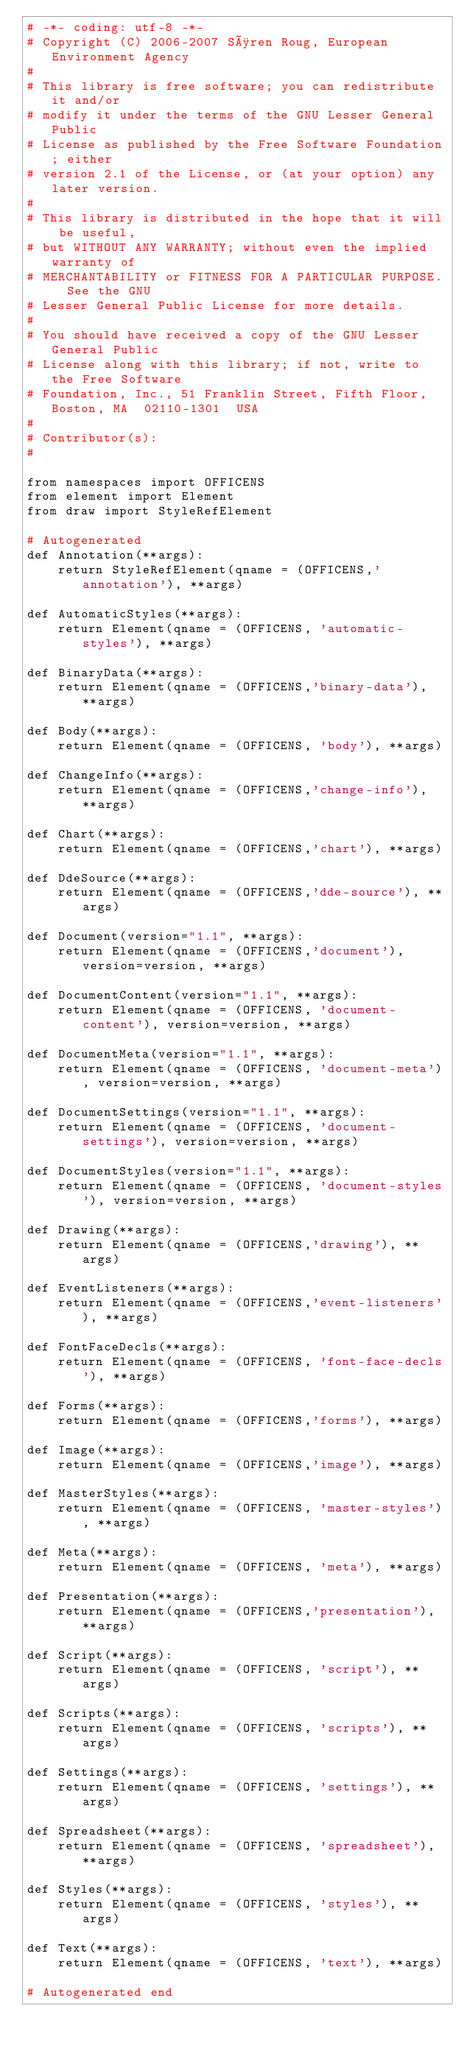<code> <loc_0><loc_0><loc_500><loc_500><_Python_># -*- coding: utf-8 -*-
# Copyright (C) 2006-2007 Søren Roug, European Environment Agency
#
# This library is free software; you can redistribute it and/or
# modify it under the terms of the GNU Lesser General Public
# License as published by the Free Software Foundation; either
# version 2.1 of the License, or (at your option) any later version.
#
# This library is distributed in the hope that it will be useful,
# but WITHOUT ANY WARRANTY; without even the implied warranty of
# MERCHANTABILITY or FITNESS FOR A PARTICULAR PURPOSE.  See the GNU
# Lesser General Public License for more details.
#
# You should have received a copy of the GNU Lesser General Public
# License along with this library; if not, write to the Free Software
# Foundation, Inc., 51 Franklin Street, Fifth Floor, Boston, MA  02110-1301  USA
#
# Contributor(s):
#

from namespaces import OFFICENS
from element import Element
from draw import StyleRefElement

# Autogenerated
def Annotation(**args):
    return StyleRefElement(qname = (OFFICENS,'annotation'), **args)

def AutomaticStyles(**args):
    return Element(qname = (OFFICENS, 'automatic-styles'), **args)

def BinaryData(**args):
    return Element(qname = (OFFICENS,'binary-data'), **args)

def Body(**args):
    return Element(qname = (OFFICENS, 'body'), **args)

def ChangeInfo(**args):
    return Element(qname = (OFFICENS,'change-info'), **args)

def Chart(**args):
    return Element(qname = (OFFICENS,'chart'), **args)

def DdeSource(**args):
    return Element(qname = (OFFICENS,'dde-source'), **args)

def Document(version="1.1", **args):
    return Element(qname = (OFFICENS,'document'), version=version, **args)

def DocumentContent(version="1.1", **args):
    return Element(qname = (OFFICENS, 'document-content'), version=version, **args)

def DocumentMeta(version="1.1", **args):
    return Element(qname = (OFFICENS, 'document-meta'), version=version, **args)

def DocumentSettings(version="1.1", **args):
    return Element(qname = (OFFICENS, 'document-settings'), version=version, **args)

def DocumentStyles(version="1.1", **args):
    return Element(qname = (OFFICENS, 'document-styles'), version=version, **args)

def Drawing(**args):
    return Element(qname = (OFFICENS,'drawing'), **args)

def EventListeners(**args):
    return Element(qname = (OFFICENS,'event-listeners'), **args)

def FontFaceDecls(**args):
    return Element(qname = (OFFICENS, 'font-face-decls'), **args)

def Forms(**args):
    return Element(qname = (OFFICENS,'forms'), **args)

def Image(**args):
    return Element(qname = (OFFICENS,'image'), **args)

def MasterStyles(**args):
    return Element(qname = (OFFICENS, 'master-styles'), **args)

def Meta(**args):
    return Element(qname = (OFFICENS, 'meta'), **args)

def Presentation(**args):
    return Element(qname = (OFFICENS,'presentation'), **args)

def Script(**args):
    return Element(qname = (OFFICENS, 'script'), **args)

def Scripts(**args):
    return Element(qname = (OFFICENS, 'scripts'), **args)

def Settings(**args):
    return Element(qname = (OFFICENS, 'settings'), **args)

def Spreadsheet(**args):
    return Element(qname = (OFFICENS, 'spreadsheet'), **args)

def Styles(**args):
    return Element(qname = (OFFICENS, 'styles'), **args)

def Text(**args):
    return Element(qname = (OFFICENS, 'text'), **args)

# Autogenerated end
</code> 